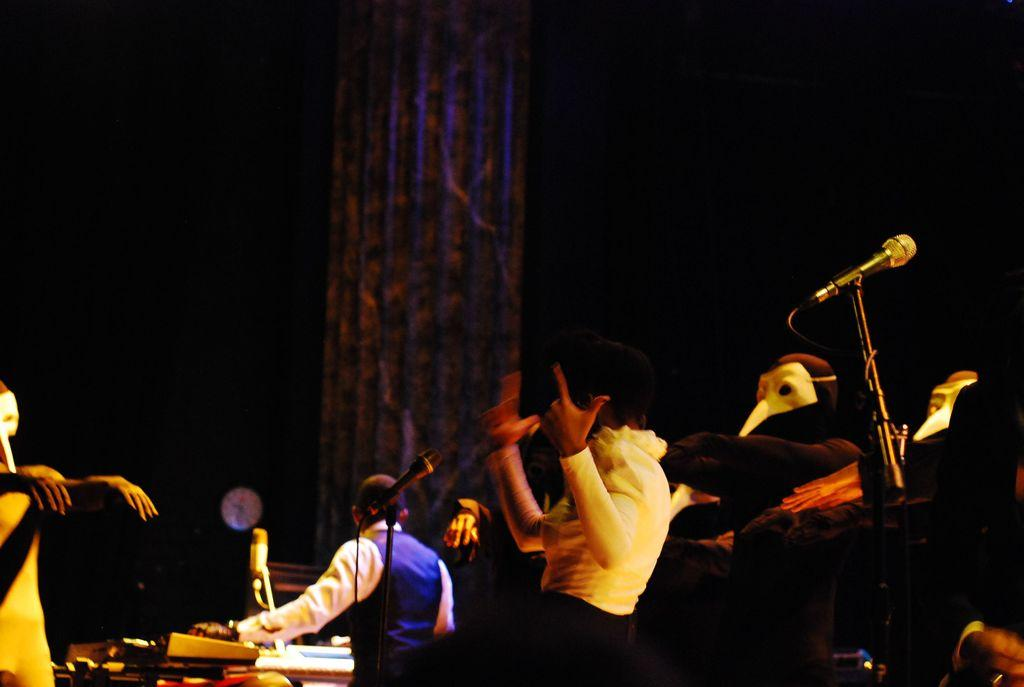What event is taking place in the image? The image is taken at a music concert. Can you describe the people in the image? There are people in the image, but their specific actions or appearances are not mentioned in the provided facts. What equipment is visible in the image? There are microphones (mics) in the image. How many chickens can be seen in the image? There are no chickens present in the image. What type of pollution is visible in the image? There is no reference to pollution in the image, as it features a music concert. 